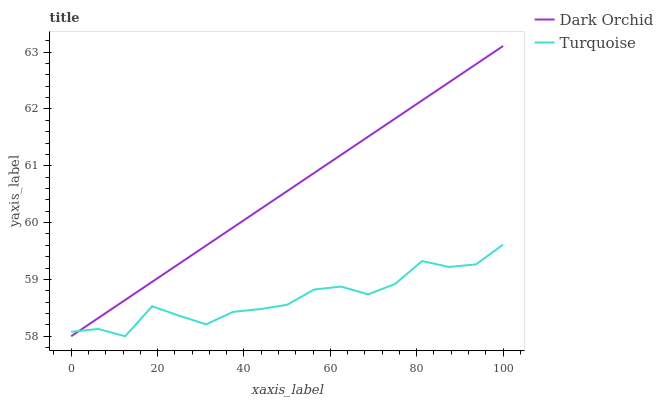Does Turquoise have the minimum area under the curve?
Answer yes or no. Yes. Does Dark Orchid have the maximum area under the curve?
Answer yes or no. Yes. Does Dark Orchid have the minimum area under the curve?
Answer yes or no. No. Is Dark Orchid the smoothest?
Answer yes or no. Yes. Is Turquoise the roughest?
Answer yes or no. Yes. Is Dark Orchid the roughest?
Answer yes or no. No. Does Dark Orchid have the highest value?
Answer yes or no. Yes. Does Dark Orchid intersect Turquoise?
Answer yes or no. Yes. Is Dark Orchid less than Turquoise?
Answer yes or no. No. Is Dark Orchid greater than Turquoise?
Answer yes or no. No. 